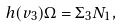<formula> <loc_0><loc_0><loc_500><loc_500>h ( v _ { 3 } ) \Omega = \Sigma _ { 3 } N _ { 1 } ,</formula> 